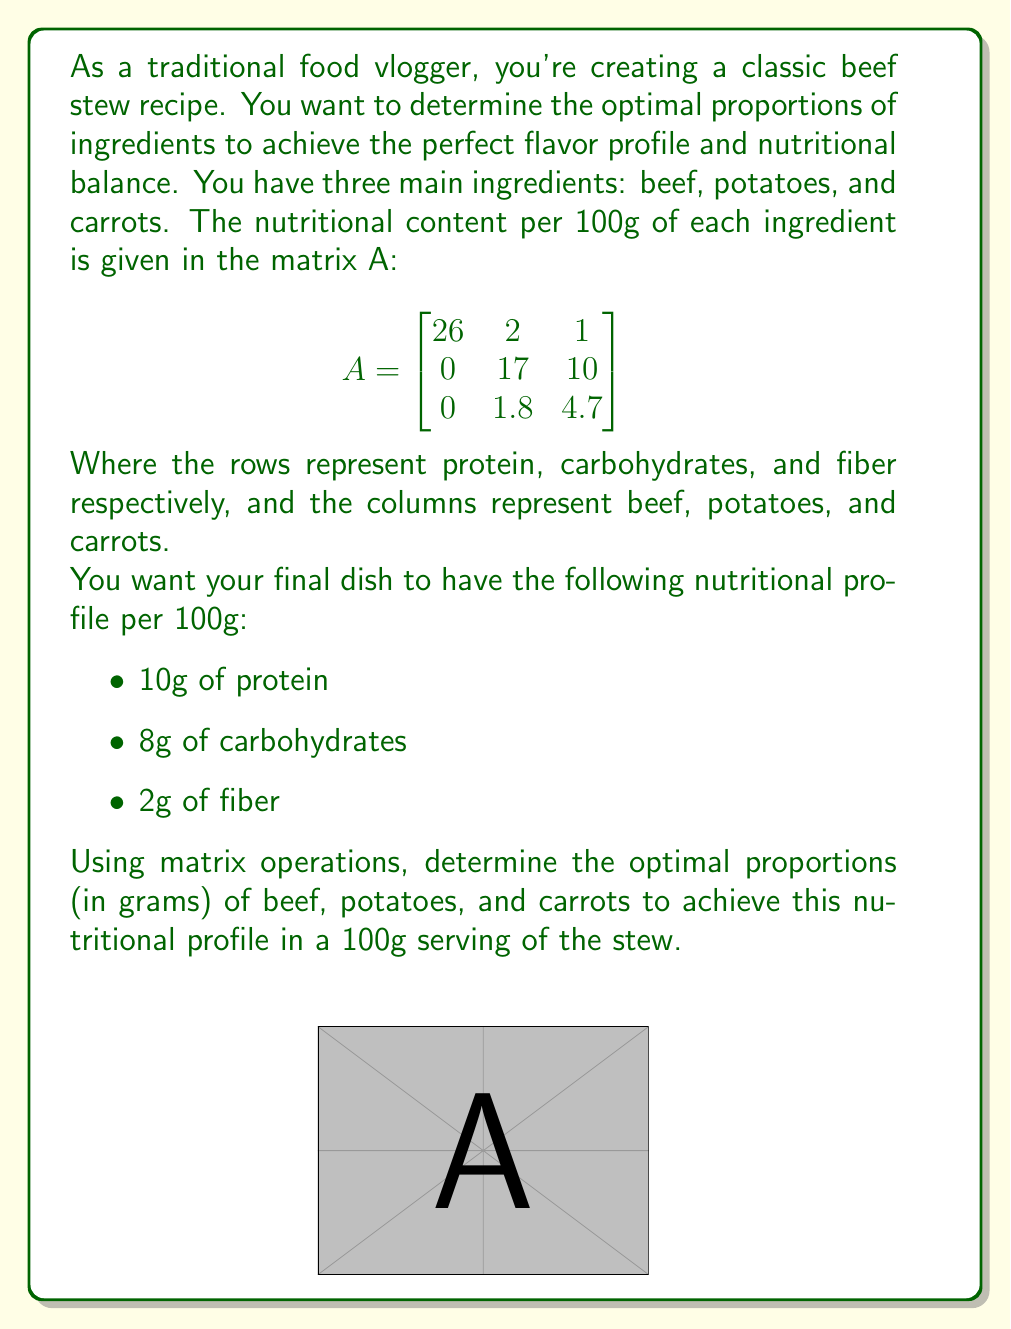Give your solution to this math problem. Let's approach this step-by-step:

1) Let x, y, and z represent the amounts (in grams) of beef, potatoes, and carrots respectively. We need to find these values.

2) We can represent our desired nutritional profile as a column vector b:

   $$b = \begin{bmatrix} 10 \\ 8 \\ 2 \end{bmatrix}$$

3) Our problem can be represented by the matrix equation:

   $$A \begin{bmatrix} x \\ y \\ z \end{bmatrix} = b$$

4) To solve this, we need to find the inverse of matrix A and multiply both sides by it:

   $$A^{-1}A \begin{bmatrix} x \\ y \\ z \end{bmatrix} = A^{-1}b$$

5) First, let's calculate $A^{-1}$:

   $$A^{-1} = \begin{bmatrix}
   0.0385 & -0.0045 & -0.0037 \\
   -0.0023 & 0.0618 & -0.0118 \\
   -0.0082 & -0.0364 & 0.2236
   \end{bmatrix}$$

6) Now, we can solve for x, y, and z:

   $$\begin{bmatrix} x \\ y \\ z \end{bmatrix} = A^{-1}b = \begin{bmatrix}
   0.0385 & -0.0045 & -0.0037 \\
   -0.0023 & 0.0618 & -0.0118 \\
   -0.0082 & -0.0364 & 0.2236
   \end{bmatrix} \begin{bmatrix} 10 \\ 8 \\ 2 \end{bmatrix}$$

7) Calculating this gives us:

   $$\begin{bmatrix} x \\ y \\ z \end{bmatrix} = \begin{bmatrix} 0.3458 \\ 0.4472 \\ 0.2070 \end{bmatrix}$$

8) Multiplying by 100 to get the grams in a 100g serving:

   $$\begin{bmatrix} 34.58 \\ 44.72 \\ 20.70 \end{bmatrix}$$

Therefore, the optimal proportions for a 100g serving are approximately 34.58g of beef, 44.72g of potatoes, and 20.70g of carrots.
Answer: 34.58g beef, 44.72g potatoes, 20.70g carrots 